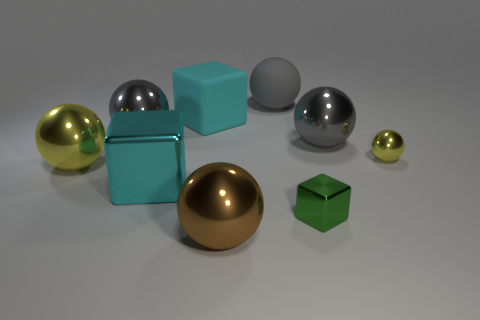How many gray spheres must be subtracted to get 1 gray spheres? 2 Subtract all big matte cubes. How many cubes are left? 2 Subtract all brown spheres. How many spheres are left? 5 Subtract all spheres. How many objects are left? 3 Add 1 green things. How many objects exist? 10 Subtract 0 purple cylinders. How many objects are left? 9 Subtract 3 cubes. How many cubes are left? 0 Subtract all blue balls. Subtract all green cylinders. How many balls are left? 6 Subtract all yellow cylinders. How many red spheres are left? 0 Subtract all blue rubber balls. Subtract all tiny balls. How many objects are left? 8 